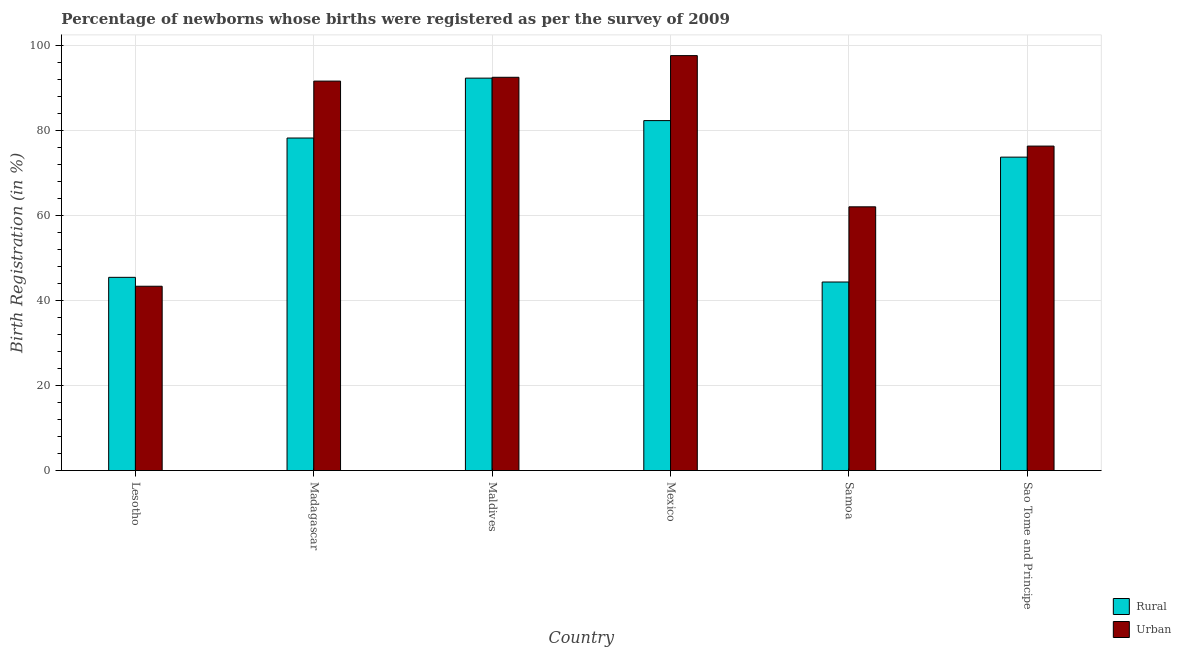Are the number of bars per tick equal to the number of legend labels?
Your answer should be compact. Yes. What is the label of the 2nd group of bars from the left?
Provide a short and direct response. Madagascar. In how many cases, is the number of bars for a given country not equal to the number of legend labels?
Your answer should be compact. 0. What is the urban birth registration in Maldives?
Provide a short and direct response. 92.6. Across all countries, what is the maximum urban birth registration?
Ensure brevity in your answer.  97.7. Across all countries, what is the minimum urban birth registration?
Give a very brief answer. 43.4. In which country was the urban birth registration maximum?
Ensure brevity in your answer.  Mexico. In which country was the urban birth registration minimum?
Your answer should be compact. Lesotho. What is the total urban birth registration in the graph?
Your answer should be compact. 463.9. What is the difference between the urban birth registration in Madagascar and that in Samoa?
Your answer should be compact. 29.6. What is the difference between the rural birth registration in Mexico and the urban birth registration in Sao Tome and Principe?
Keep it short and to the point. 6. What is the average urban birth registration per country?
Give a very brief answer. 77.32. What is the difference between the urban birth registration and rural birth registration in Samoa?
Give a very brief answer. 17.7. What is the ratio of the urban birth registration in Maldives to that in Samoa?
Offer a very short reply. 1.49. Is the urban birth registration in Mexico less than that in Samoa?
Make the answer very short. No. What is the difference between the highest and the second highest urban birth registration?
Offer a very short reply. 5.1. What is the difference between the highest and the lowest rural birth registration?
Give a very brief answer. 48. Is the sum of the urban birth registration in Lesotho and Madagascar greater than the maximum rural birth registration across all countries?
Ensure brevity in your answer.  Yes. What does the 2nd bar from the left in Mexico represents?
Give a very brief answer. Urban. What does the 1st bar from the right in Samoa represents?
Provide a succinct answer. Urban. How many bars are there?
Your response must be concise. 12. Are all the bars in the graph horizontal?
Provide a short and direct response. No. How many countries are there in the graph?
Offer a very short reply. 6. Are the values on the major ticks of Y-axis written in scientific E-notation?
Ensure brevity in your answer.  No. Does the graph contain any zero values?
Your answer should be compact. No. Where does the legend appear in the graph?
Offer a very short reply. Bottom right. How many legend labels are there?
Provide a short and direct response. 2. How are the legend labels stacked?
Offer a terse response. Vertical. What is the title of the graph?
Make the answer very short. Percentage of newborns whose births were registered as per the survey of 2009. Does "Private credit bureau" appear as one of the legend labels in the graph?
Ensure brevity in your answer.  No. What is the label or title of the Y-axis?
Offer a terse response. Birth Registration (in %). What is the Birth Registration (in %) of Rural in Lesotho?
Offer a terse response. 45.5. What is the Birth Registration (in %) of Urban in Lesotho?
Provide a short and direct response. 43.4. What is the Birth Registration (in %) in Rural in Madagascar?
Your answer should be compact. 78.3. What is the Birth Registration (in %) in Urban in Madagascar?
Ensure brevity in your answer.  91.7. What is the Birth Registration (in %) in Rural in Maldives?
Ensure brevity in your answer.  92.4. What is the Birth Registration (in %) in Urban in Maldives?
Keep it short and to the point. 92.6. What is the Birth Registration (in %) in Rural in Mexico?
Your answer should be compact. 82.4. What is the Birth Registration (in %) of Urban in Mexico?
Give a very brief answer. 97.7. What is the Birth Registration (in %) in Rural in Samoa?
Your response must be concise. 44.4. What is the Birth Registration (in %) of Urban in Samoa?
Give a very brief answer. 62.1. What is the Birth Registration (in %) of Rural in Sao Tome and Principe?
Provide a short and direct response. 73.8. What is the Birth Registration (in %) of Urban in Sao Tome and Principe?
Ensure brevity in your answer.  76.4. Across all countries, what is the maximum Birth Registration (in %) in Rural?
Make the answer very short. 92.4. Across all countries, what is the maximum Birth Registration (in %) in Urban?
Offer a very short reply. 97.7. Across all countries, what is the minimum Birth Registration (in %) in Rural?
Ensure brevity in your answer.  44.4. Across all countries, what is the minimum Birth Registration (in %) of Urban?
Make the answer very short. 43.4. What is the total Birth Registration (in %) in Rural in the graph?
Keep it short and to the point. 416.8. What is the total Birth Registration (in %) of Urban in the graph?
Offer a very short reply. 463.9. What is the difference between the Birth Registration (in %) of Rural in Lesotho and that in Madagascar?
Provide a succinct answer. -32.8. What is the difference between the Birth Registration (in %) in Urban in Lesotho and that in Madagascar?
Your answer should be compact. -48.3. What is the difference between the Birth Registration (in %) in Rural in Lesotho and that in Maldives?
Keep it short and to the point. -46.9. What is the difference between the Birth Registration (in %) in Urban in Lesotho and that in Maldives?
Ensure brevity in your answer.  -49.2. What is the difference between the Birth Registration (in %) in Rural in Lesotho and that in Mexico?
Ensure brevity in your answer.  -36.9. What is the difference between the Birth Registration (in %) in Urban in Lesotho and that in Mexico?
Give a very brief answer. -54.3. What is the difference between the Birth Registration (in %) of Urban in Lesotho and that in Samoa?
Offer a very short reply. -18.7. What is the difference between the Birth Registration (in %) in Rural in Lesotho and that in Sao Tome and Principe?
Ensure brevity in your answer.  -28.3. What is the difference between the Birth Registration (in %) in Urban in Lesotho and that in Sao Tome and Principe?
Provide a short and direct response. -33. What is the difference between the Birth Registration (in %) of Rural in Madagascar and that in Maldives?
Provide a succinct answer. -14.1. What is the difference between the Birth Registration (in %) in Urban in Madagascar and that in Maldives?
Provide a short and direct response. -0.9. What is the difference between the Birth Registration (in %) in Rural in Madagascar and that in Mexico?
Make the answer very short. -4.1. What is the difference between the Birth Registration (in %) in Rural in Madagascar and that in Samoa?
Your answer should be compact. 33.9. What is the difference between the Birth Registration (in %) of Urban in Madagascar and that in Samoa?
Your answer should be very brief. 29.6. What is the difference between the Birth Registration (in %) in Rural in Madagascar and that in Sao Tome and Principe?
Make the answer very short. 4.5. What is the difference between the Birth Registration (in %) of Urban in Madagascar and that in Sao Tome and Principe?
Your answer should be very brief. 15.3. What is the difference between the Birth Registration (in %) of Rural in Maldives and that in Mexico?
Make the answer very short. 10. What is the difference between the Birth Registration (in %) in Urban in Maldives and that in Samoa?
Give a very brief answer. 30.5. What is the difference between the Birth Registration (in %) in Rural in Maldives and that in Sao Tome and Principe?
Your response must be concise. 18.6. What is the difference between the Birth Registration (in %) in Urban in Mexico and that in Samoa?
Your answer should be very brief. 35.6. What is the difference between the Birth Registration (in %) of Urban in Mexico and that in Sao Tome and Principe?
Make the answer very short. 21.3. What is the difference between the Birth Registration (in %) of Rural in Samoa and that in Sao Tome and Principe?
Offer a terse response. -29.4. What is the difference between the Birth Registration (in %) in Urban in Samoa and that in Sao Tome and Principe?
Offer a terse response. -14.3. What is the difference between the Birth Registration (in %) in Rural in Lesotho and the Birth Registration (in %) in Urban in Madagascar?
Provide a succinct answer. -46.2. What is the difference between the Birth Registration (in %) in Rural in Lesotho and the Birth Registration (in %) in Urban in Maldives?
Make the answer very short. -47.1. What is the difference between the Birth Registration (in %) of Rural in Lesotho and the Birth Registration (in %) of Urban in Mexico?
Ensure brevity in your answer.  -52.2. What is the difference between the Birth Registration (in %) of Rural in Lesotho and the Birth Registration (in %) of Urban in Samoa?
Make the answer very short. -16.6. What is the difference between the Birth Registration (in %) of Rural in Lesotho and the Birth Registration (in %) of Urban in Sao Tome and Principe?
Offer a terse response. -30.9. What is the difference between the Birth Registration (in %) of Rural in Madagascar and the Birth Registration (in %) of Urban in Maldives?
Provide a short and direct response. -14.3. What is the difference between the Birth Registration (in %) of Rural in Madagascar and the Birth Registration (in %) of Urban in Mexico?
Offer a very short reply. -19.4. What is the difference between the Birth Registration (in %) of Rural in Madagascar and the Birth Registration (in %) of Urban in Sao Tome and Principe?
Your response must be concise. 1.9. What is the difference between the Birth Registration (in %) of Rural in Maldives and the Birth Registration (in %) of Urban in Mexico?
Keep it short and to the point. -5.3. What is the difference between the Birth Registration (in %) of Rural in Maldives and the Birth Registration (in %) of Urban in Samoa?
Your answer should be very brief. 30.3. What is the difference between the Birth Registration (in %) in Rural in Mexico and the Birth Registration (in %) in Urban in Samoa?
Provide a succinct answer. 20.3. What is the difference between the Birth Registration (in %) of Rural in Samoa and the Birth Registration (in %) of Urban in Sao Tome and Principe?
Ensure brevity in your answer.  -32. What is the average Birth Registration (in %) in Rural per country?
Make the answer very short. 69.47. What is the average Birth Registration (in %) in Urban per country?
Provide a short and direct response. 77.32. What is the difference between the Birth Registration (in %) in Rural and Birth Registration (in %) in Urban in Lesotho?
Keep it short and to the point. 2.1. What is the difference between the Birth Registration (in %) in Rural and Birth Registration (in %) in Urban in Maldives?
Your response must be concise. -0.2. What is the difference between the Birth Registration (in %) in Rural and Birth Registration (in %) in Urban in Mexico?
Your answer should be compact. -15.3. What is the difference between the Birth Registration (in %) of Rural and Birth Registration (in %) of Urban in Samoa?
Provide a succinct answer. -17.7. What is the difference between the Birth Registration (in %) of Rural and Birth Registration (in %) of Urban in Sao Tome and Principe?
Offer a terse response. -2.6. What is the ratio of the Birth Registration (in %) in Rural in Lesotho to that in Madagascar?
Make the answer very short. 0.58. What is the ratio of the Birth Registration (in %) of Urban in Lesotho to that in Madagascar?
Offer a terse response. 0.47. What is the ratio of the Birth Registration (in %) of Rural in Lesotho to that in Maldives?
Offer a very short reply. 0.49. What is the ratio of the Birth Registration (in %) in Urban in Lesotho to that in Maldives?
Ensure brevity in your answer.  0.47. What is the ratio of the Birth Registration (in %) in Rural in Lesotho to that in Mexico?
Your response must be concise. 0.55. What is the ratio of the Birth Registration (in %) in Urban in Lesotho to that in Mexico?
Your response must be concise. 0.44. What is the ratio of the Birth Registration (in %) of Rural in Lesotho to that in Samoa?
Provide a succinct answer. 1.02. What is the ratio of the Birth Registration (in %) in Urban in Lesotho to that in Samoa?
Provide a short and direct response. 0.7. What is the ratio of the Birth Registration (in %) of Rural in Lesotho to that in Sao Tome and Principe?
Provide a short and direct response. 0.62. What is the ratio of the Birth Registration (in %) of Urban in Lesotho to that in Sao Tome and Principe?
Offer a terse response. 0.57. What is the ratio of the Birth Registration (in %) in Rural in Madagascar to that in Maldives?
Your answer should be compact. 0.85. What is the ratio of the Birth Registration (in %) of Urban in Madagascar to that in Maldives?
Your response must be concise. 0.99. What is the ratio of the Birth Registration (in %) in Rural in Madagascar to that in Mexico?
Give a very brief answer. 0.95. What is the ratio of the Birth Registration (in %) of Urban in Madagascar to that in Mexico?
Make the answer very short. 0.94. What is the ratio of the Birth Registration (in %) in Rural in Madagascar to that in Samoa?
Provide a short and direct response. 1.76. What is the ratio of the Birth Registration (in %) in Urban in Madagascar to that in Samoa?
Offer a terse response. 1.48. What is the ratio of the Birth Registration (in %) in Rural in Madagascar to that in Sao Tome and Principe?
Your answer should be very brief. 1.06. What is the ratio of the Birth Registration (in %) in Urban in Madagascar to that in Sao Tome and Principe?
Provide a succinct answer. 1.2. What is the ratio of the Birth Registration (in %) in Rural in Maldives to that in Mexico?
Your answer should be very brief. 1.12. What is the ratio of the Birth Registration (in %) in Urban in Maldives to that in Mexico?
Your answer should be compact. 0.95. What is the ratio of the Birth Registration (in %) in Rural in Maldives to that in Samoa?
Your answer should be very brief. 2.08. What is the ratio of the Birth Registration (in %) in Urban in Maldives to that in Samoa?
Ensure brevity in your answer.  1.49. What is the ratio of the Birth Registration (in %) of Rural in Maldives to that in Sao Tome and Principe?
Give a very brief answer. 1.25. What is the ratio of the Birth Registration (in %) in Urban in Maldives to that in Sao Tome and Principe?
Your answer should be very brief. 1.21. What is the ratio of the Birth Registration (in %) in Rural in Mexico to that in Samoa?
Your answer should be very brief. 1.86. What is the ratio of the Birth Registration (in %) of Urban in Mexico to that in Samoa?
Ensure brevity in your answer.  1.57. What is the ratio of the Birth Registration (in %) of Rural in Mexico to that in Sao Tome and Principe?
Give a very brief answer. 1.12. What is the ratio of the Birth Registration (in %) of Urban in Mexico to that in Sao Tome and Principe?
Your response must be concise. 1.28. What is the ratio of the Birth Registration (in %) in Rural in Samoa to that in Sao Tome and Principe?
Offer a very short reply. 0.6. What is the ratio of the Birth Registration (in %) in Urban in Samoa to that in Sao Tome and Principe?
Your answer should be compact. 0.81. What is the difference between the highest and the second highest Birth Registration (in %) in Urban?
Give a very brief answer. 5.1. What is the difference between the highest and the lowest Birth Registration (in %) in Rural?
Ensure brevity in your answer.  48. What is the difference between the highest and the lowest Birth Registration (in %) of Urban?
Give a very brief answer. 54.3. 